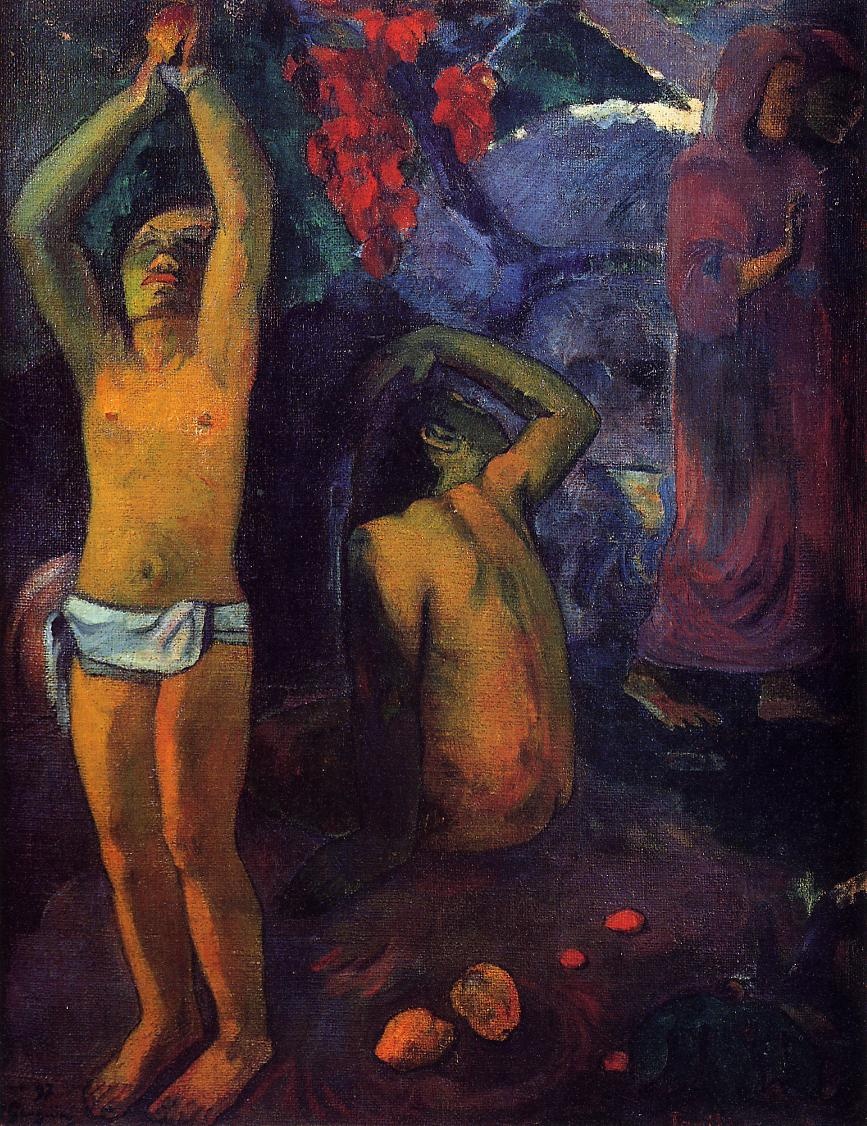Write a detailed description of the given image. The depicted image is an oil painting titled "Where Do We Come From? What Are We? Where Are We Going?" by Paul Gauguin, a pivotal figure in the post-impressionist movement. This artwork, created during Gauguin's time in Tahiti, spans over three meters in width and is packed with symbolism and existential questions about the human experience. It features a lush, vibrant background of a tropical Tahitian landscape with rich flora, and hosts multiple figures in various stages of life, from a newborn to an elderly woman, signifying the cycle of life. The central figure, a young man with arms outstretched upwards, dominates the scene, possibly symbolizing the universal quest for understanding. By his side, two women appear deeply contemplative or engaged in daily activities, further enhancing the painting's narrative on human existence. Gauguin’s use of bold, expressive colors and abstract forms not only underscores the emotional depth of the scene but also reflects his departure from European artistic norms, venturing into avant-garde territories with a focus on existential and primitive themes. 